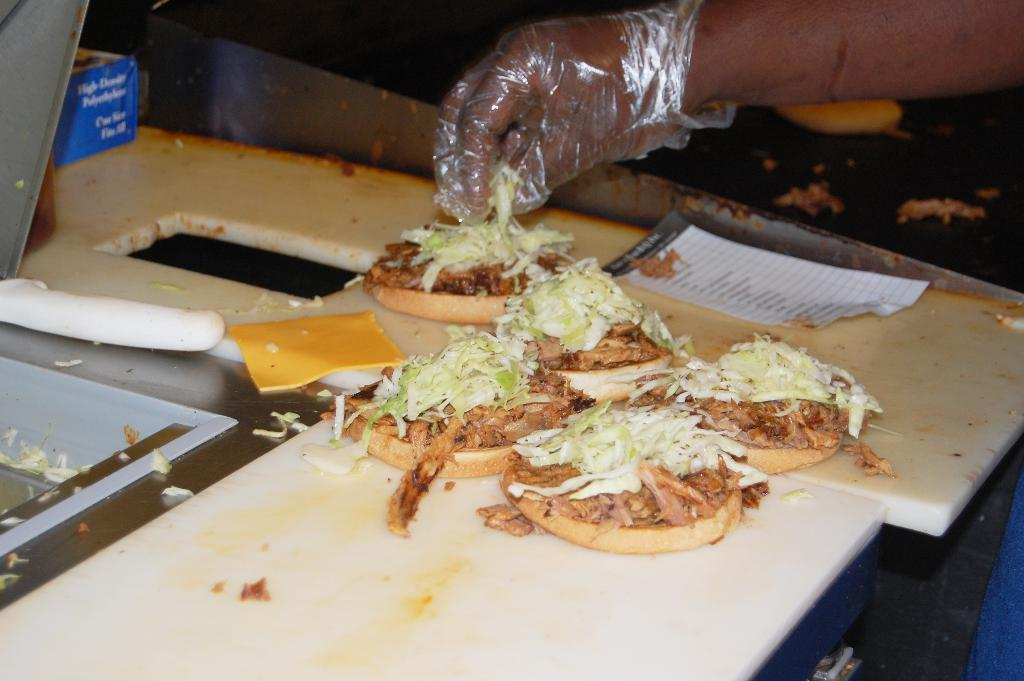What is the main subject of the image? The main subject of the image is pizzas. Where are the pizzas located in the image? The pizzas are placed on a table in the center of the image. Can you describe the person's hand visible in the image? A person's hand is visible in the image, but it is not clear what the person is doing. Are there any other pizzas visible in the image? Yes, there is at least one pizza visible in the background of the image, and it is also placed on a table. What is the weight of the net used to catch the pizzas in the image? There is no net present in the image, and the pizzas are not being caught. 